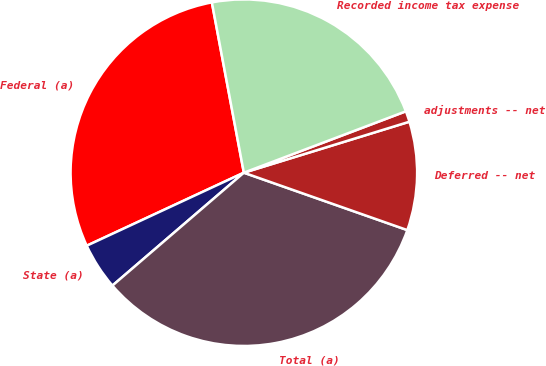Convert chart to OTSL. <chart><loc_0><loc_0><loc_500><loc_500><pie_chart><fcel>Federal (a)<fcel>State (a)<fcel>Total (a)<fcel>Deferred -- net<fcel>adjustments -- net<fcel>Recorded income tax expense<nl><fcel>28.97%<fcel>4.37%<fcel>33.33%<fcel>10.13%<fcel>1.01%<fcel>22.19%<nl></chart> 